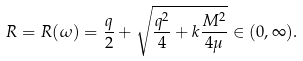Convert formula to latex. <formula><loc_0><loc_0><loc_500><loc_500>R = R ( \omega ) = \frac { q } { 2 } + \sqrt { \frac { q ^ { 2 } } { 4 } + k \frac { M ^ { 2 } } { 4 \mu } } \in ( 0 , \infty ) .</formula> 